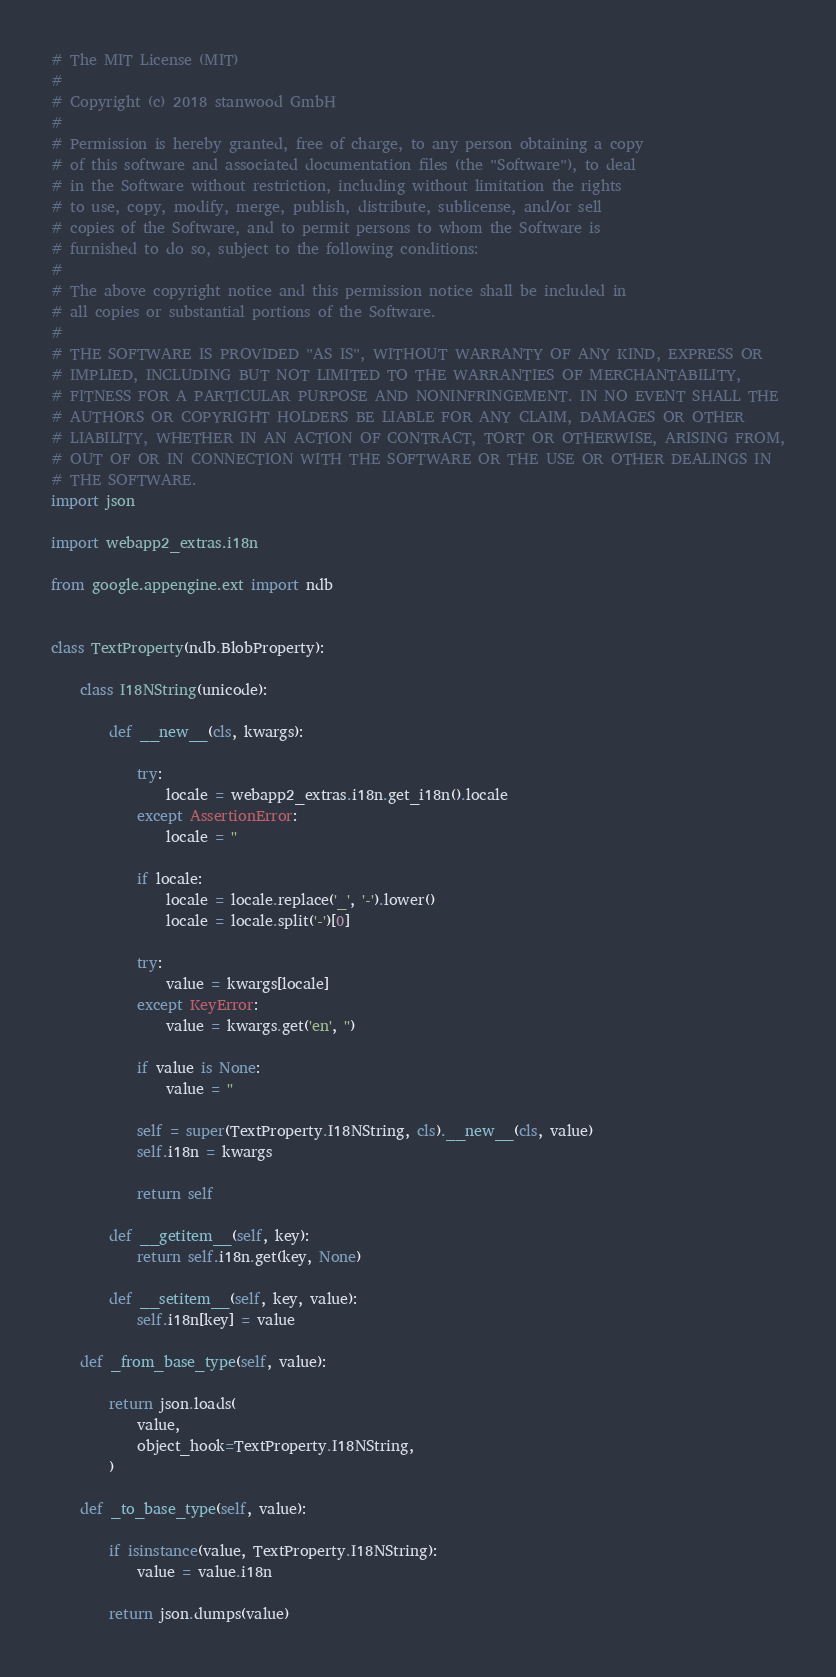<code> <loc_0><loc_0><loc_500><loc_500><_Python_># The MIT License (MIT)
# 
# Copyright (c) 2018 stanwood GmbH
# 
# Permission is hereby granted, free of charge, to any person obtaining a copy
# of this software and associated documentation files (the "Software"), to deal
# in the Software without restriction, including without limitation the rights
# to use, copy, modify, merge, publish, distribute, sublicense, and/or sell
# copies of the Software, and to permit persons to whom the Software is
# furnished to do so, subject to the following conditions:
# 
# The above copyright notice and this permission notice shall be included in
# all copies or substantial portions of the Software.
# 
# THE SOFTWARE IS PROVIDED "AS IS", WITHOUT WARRANTY OF ANY KIND, EXPRESS OR
# IMPLIED, INCLUDING BUT NOT LIMITED TO THE WARRANTIES OF MERCHANTABILITY,
# FITNESS FOR A PARTICULAR PURPOSE AND NONINFRINGEMENT. IN NO EVENT SHALL THE
# AUTHORS OR COPYRIGHT HOLDERS BE LIABLE FOR ANY CLAIM, DAMAGES OR OTHER
# LIABILITY, WHETHER IN AN ACTION OF CONTRACT, TORT OR OTHERWISE, ARISING FROM,
# OUT OF OR IN CONNECTION WITH THE SOFTWARE OR THE USE OR OTHER DEALINGS IN
# THE SOFTWARE.
import json

import webapp2_extras.i18n

from google.appengine.ext import ndb


class TextProperty(ndb.BlobProperty):

    class I18NString(unicode):

        def __new__(cls, kwargs):

            try:
                locale = webapp2_extras.i18n.get_i18n().locale
            except AssertionError:
                locale = ''

            if locale:
                locale = locale.replace('_', '-').lower()
                locale = locale.split('-')[0]

            try:
                value = kwargs[locale]
            except KeyError:
                value = kwargs.get('en', '')

            if value is None:
                value = ''

            self = super(TextProperty.I18NString, cls).__new__(cls, value)
            self.i18n = kwargs

            return self

        def __getitem__(self, key):
            return self.i18n.get(key, None)

        def __setitem__(self, key, value):
            self.i18n[key] = value

    def _from_base_type(self, value):

        return json.loads(
            value,
            object_hook=TextProperty.I18NString,
        )

    def _to_base_type(self, value):

        if isinstance(value, TextProperty.I18NString):
            value = value.i18n

        return json.dumps(value)
</code> 